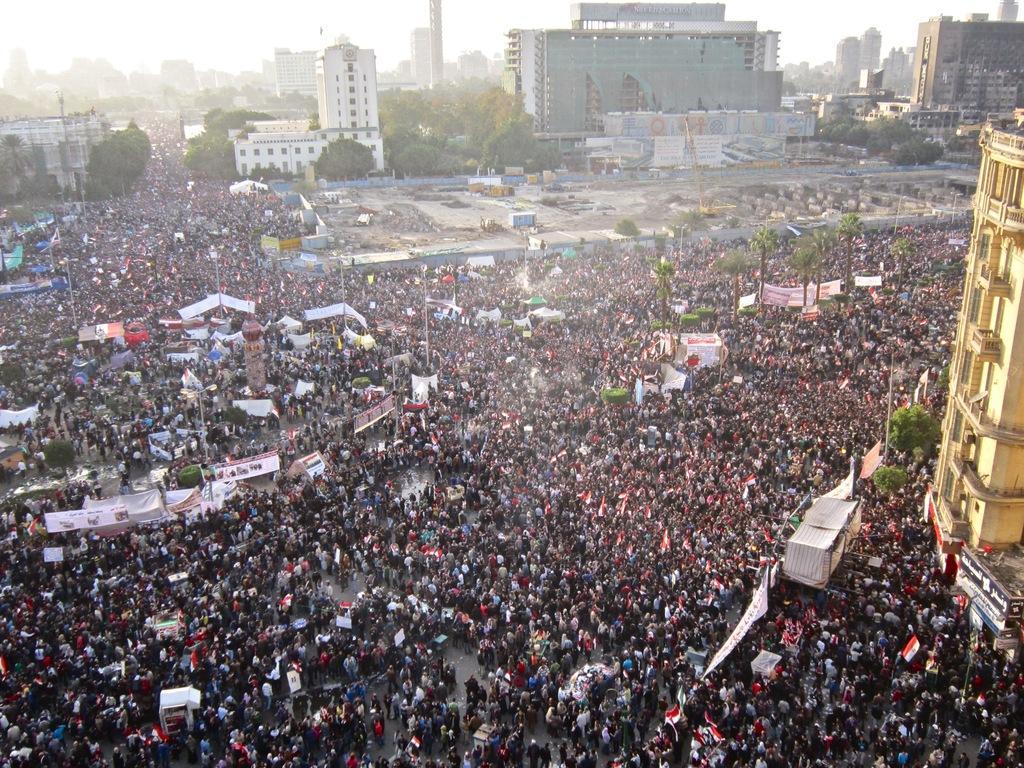Could you give a brief overview of what you see in this image? There are group of people standing. These are the banners. I can see the trees. These look like poles. These are the buildings. 